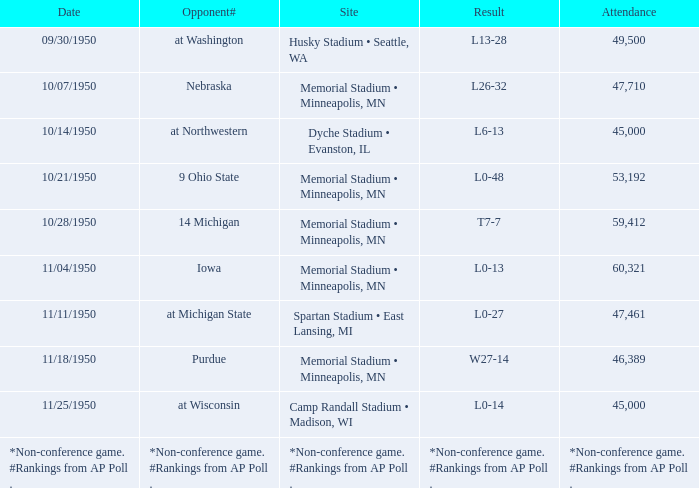What is the venue when the date is 11/11/1950? Spartan Stadium • East Lansing, MI. 